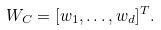<formula> <loc_0><loc_0><loc_500><loc_500>W _ { C } = [ { w } _ { 1 } , \dots , { w } _ { d } ] ^ { T } .</formula> 